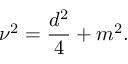<formula> <loc_0><loc_0><loc_500><loc_500>\nu ^ { 2 } = \frac { d ^ { 2 } } { 4 } + m ^ { 2 } .</formula> 